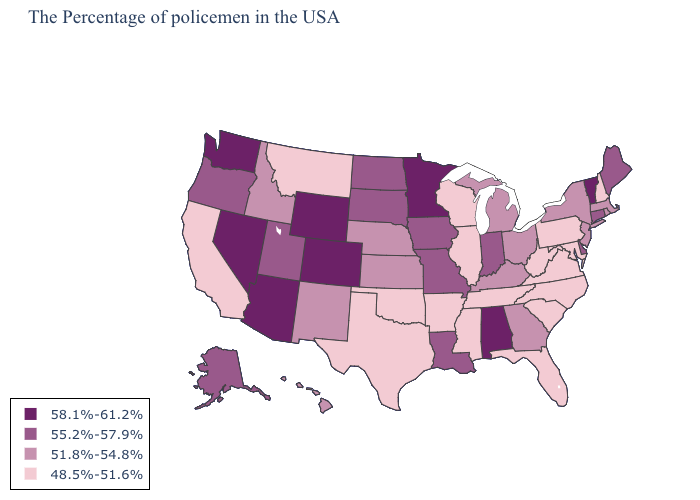Does Wisconsin have the lowest value in the USA?
Short answer required. Yes. Is the legend a continuous bar?
Write a very short answer. No. Does Vermont have the highest value in the USA?
Quick response, please. Yes. Which states have the lowest value in the South?
Keep it brief. Maryland, Virginia, North Carolina, South Carolina, West Virginia, Florida, Tennessee, Mississippi, Arkansas, Oklahoma, Texas. Does Minnesota have a lower value than North Carolina?
Give a very brief answer. No. Does Kansas have the highest value in the USA?
Write a very short answer. No. Does Indiana have the highest value in the USA?
Write a very short answer. No. Which states have the highest value in the USA?
Concise answer only. Vermont, Alabama, Minnesota, Wyoming, Colorado, Arizona, Nevada, Washington. Which states hav the highest value in the Northeast?
Answer briefly. Vermont. How many symbols are there in the legend?
Be succinct. 4. What is the highest value in states that border Oklahoma?
Be succinct. 58.1%-61.2%. Does the map have missing data?
Write a very short answer. No. Does Vermont have the highest value in the Northeast?
Write a very short answer. Yes. What is the value of Massachusetts?
Write a very short answer. 51.8%-54.8%. Which states have the highest value in the USA?
Give a very brief answer. Vermont, Alabama, Minnesota, Wyoming, Colorado, Arizona, Nevada, Washington. 